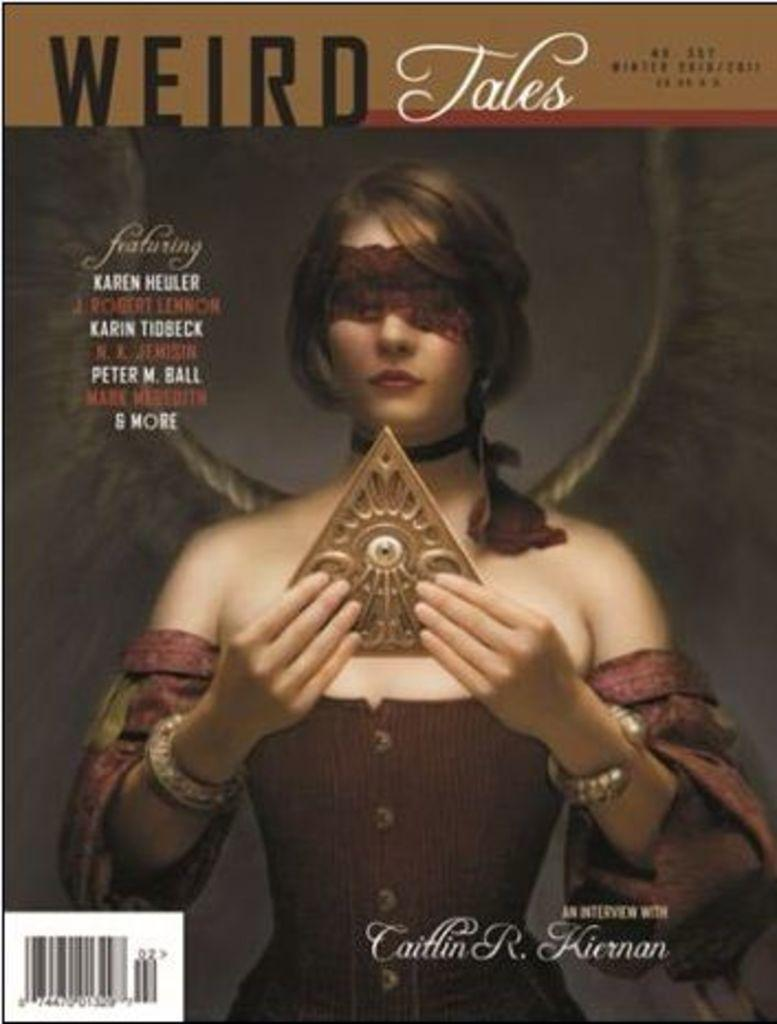<image>
Write a terse but informative summary of the picture. a copy of a WEIRD Tales magazine that says it has an interview with Caitlin R. Kiernan, & it pictures a woman on the cover. 